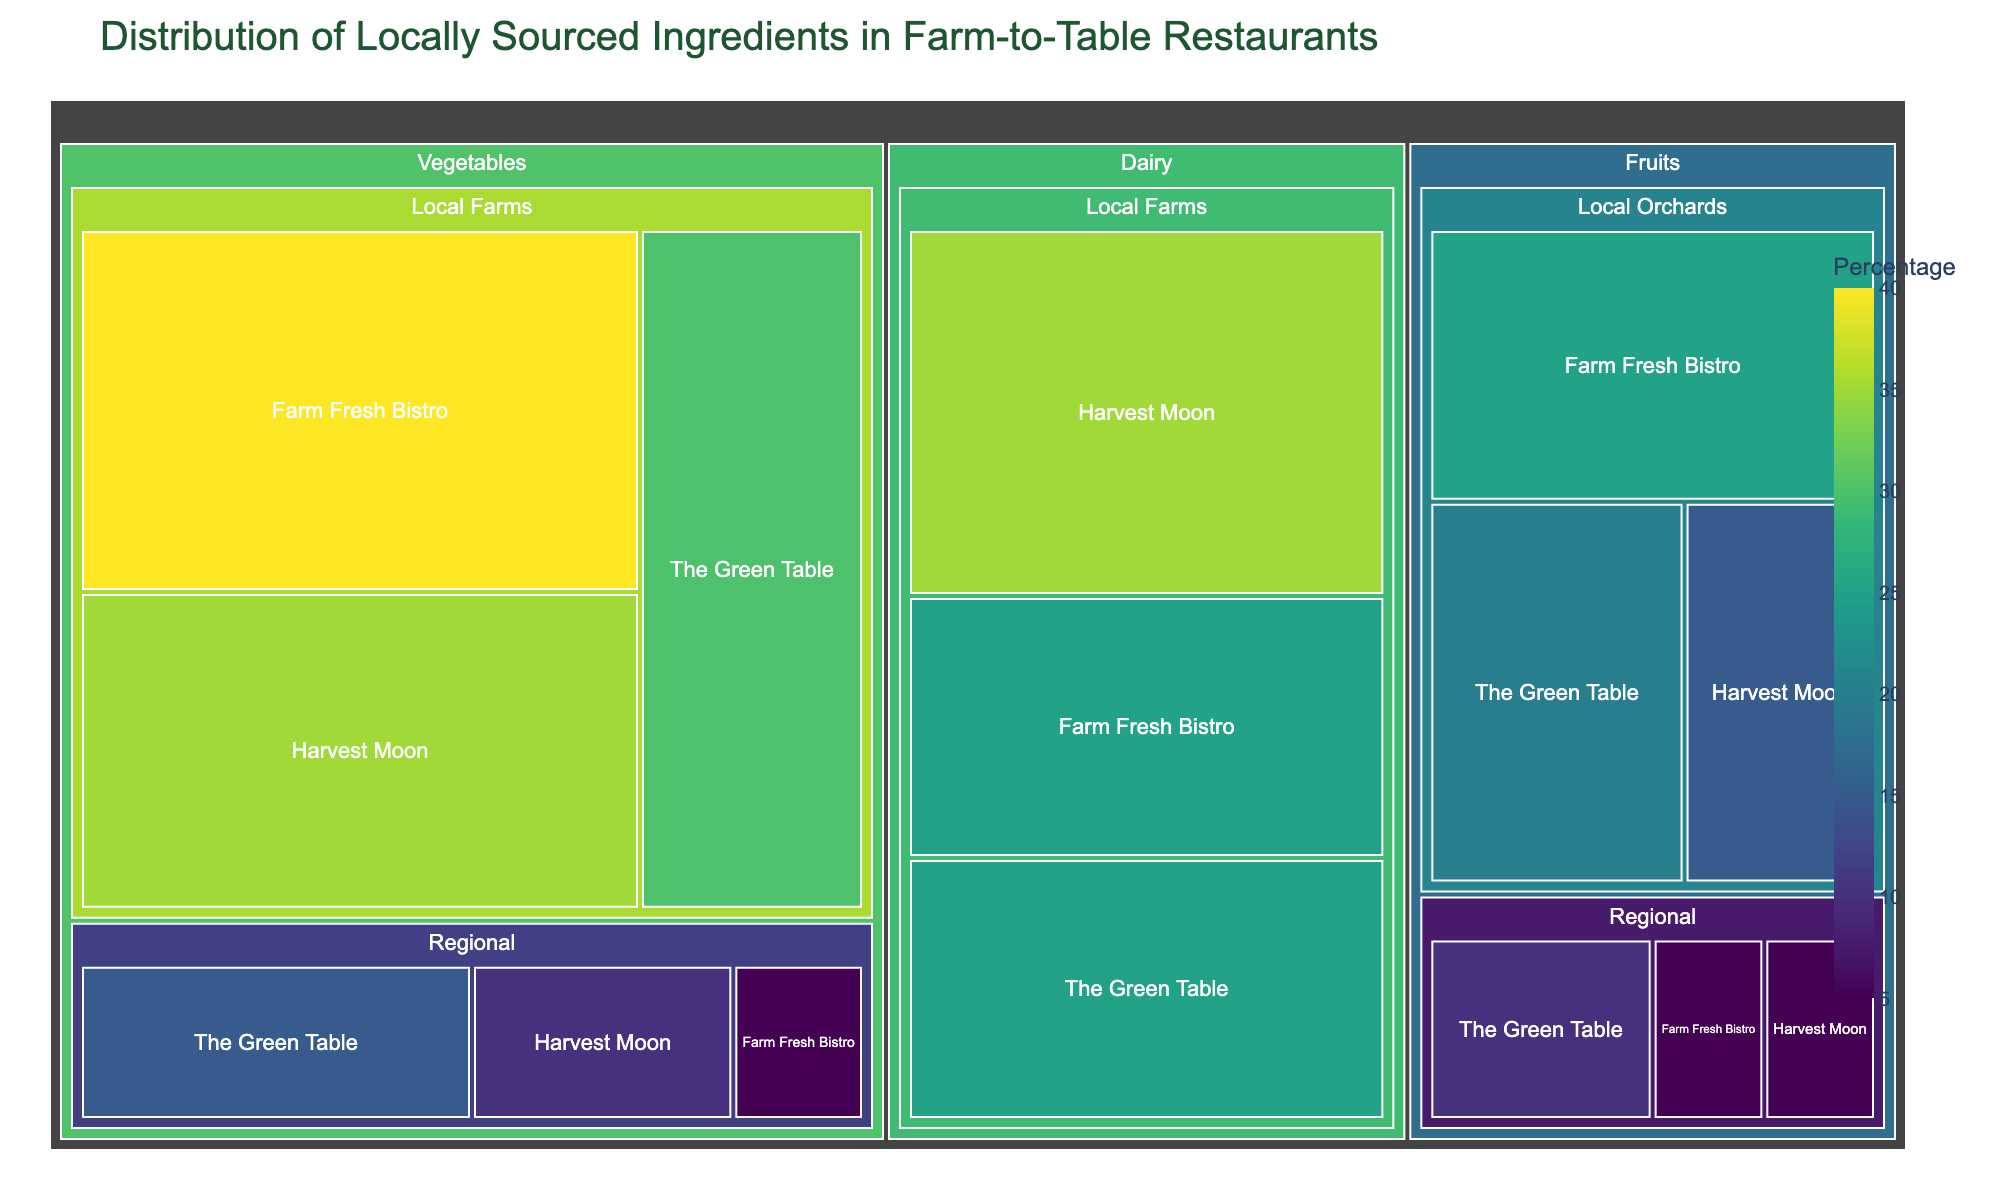What is the percentage of local vegetables used by The Green Table? To find this, locate the section for "The Green Table" under "Vegetables" and observe the percentage labeled for "Local Farms".
Answer: 30% Which restaurant uses the highest percentage of local dairy products? Compare the percentages of local dairy products used by all the restaurants. Harvest Moon and Farm Fresh Bistro both use 35%, more than The Green Table at 25%.
Answer: Harvest Moon and Farm Fresh Bistro What is the combined percentage of regional fruits used by The Green Table and Harvest Moon? Add the percentages of regional fruits for The Green Table (10%) and Harvest Moon (5%).
Answer: 15% What food type and origin combination is most used by Farm Fresh Bistro? Observe the largest percentage block for Farm Fresh Bistro. The largest is "Local Farms" under "Vegetables" with 40%.
Answer: Vegetables from Local Farms Which restaurant uses the least percentage of regional vegetables? Compare the percentages of regional vegetables used by each restaurant. Farm Fresh Bistro uses 5%, less than The Green Table (15%) and Harvest Moon (10%).
Answer: Farm Fresh Bistro How does the percentage of local fruits used by The Green Table compare to that by Harvest Moon? Compare the percentages of local fruits in The Green Table (20%) and Harvest Moon (15%).
Answer: The Green Table uses 5% more What is the average percentage of local dairy products used across all restaurants? Sum the percentages of local dairy products used by The Green Table (25%), Harvest Moon (35%), and Farm Fresh Bistro (25%), then divide by 3. (25 + 35 + 25) / 3 = 28.33%
Answer: 28.33% What is the total percentage of vegetables used by The Green Table regardless of origin? Sum the percentages of vegetables from local farms (30%) and regional (15%). 30% + 15% = 45%
Answer: 45% Which food type and origin combination has the smallest percentage for Harvest Moon? Identify the smallest block under Harvest Moon. The smallest is "Regional" for both "Fruits" (5%) and "Vegetables" (10%), with "Fruits" being the smallest.
Answer: Regional Fruits How does the use of local orchard fruits differ between The Green Table and Farm Fresh Bistro? Compare the percentages of local orchard fruits used by The Green Table (20%) and Farm Fresh Bistro (25%).
Answer: Farm Fresh Bistro uses 5% more 